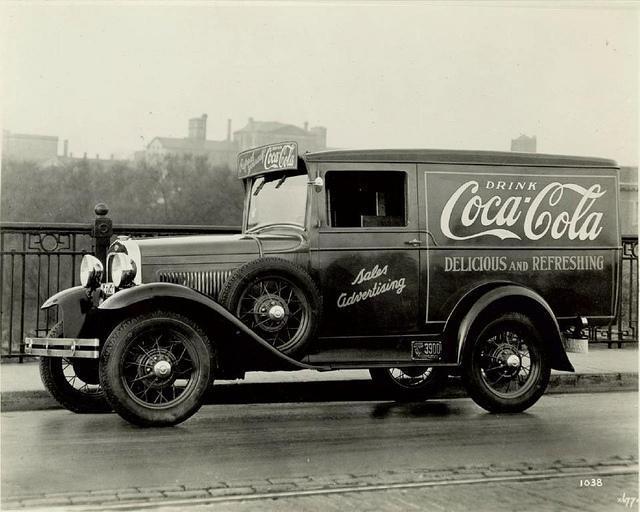How many elephants are in the picture?
Give a very brief answer. 0. 